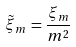<formula> <loc_0><loc_0><loc_500><loc_500>\tilde { \xi } _ { m } \, = \frac { \xi _ { m } } { m ^ { 2 } }</formula> 